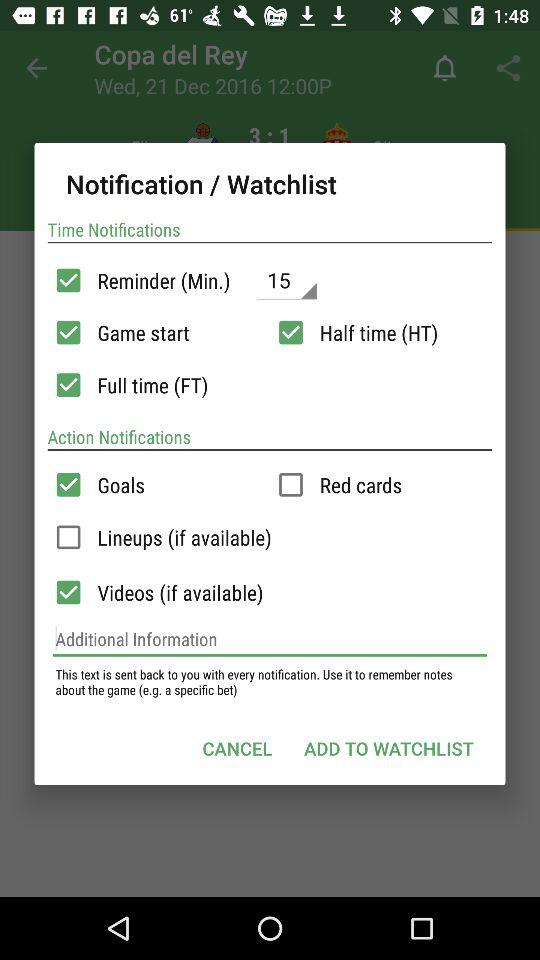How many action notifications can be selected?
Answer the question using a single word or phrase. 4 